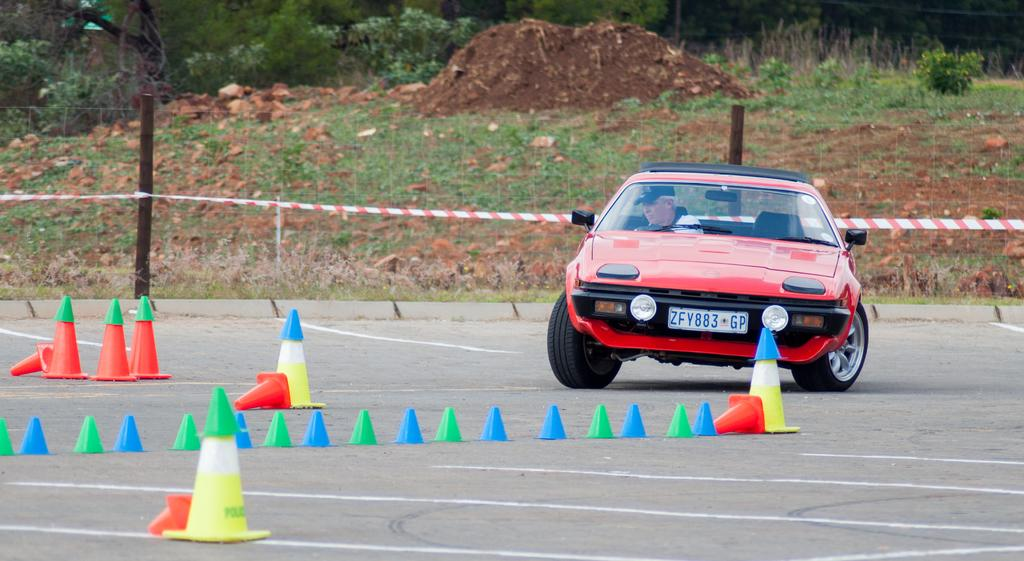What is the setting of the image? The image is an outside view. What can be seen on the road in the image? There is a car on the road in the image. Who is inside the car? A man is sitting inside the car. What type of vegetation is visible in the background? There is grass in the background, and plants are visible at the top of the image. What is the purpose of the fencing in the background? The fencing in the background serves to enclose or separate areas. What season is it in the image, and how can you tell? The provided facts do not mention any specific season or weather conditions, so it is not possible to determine the season from the image. 